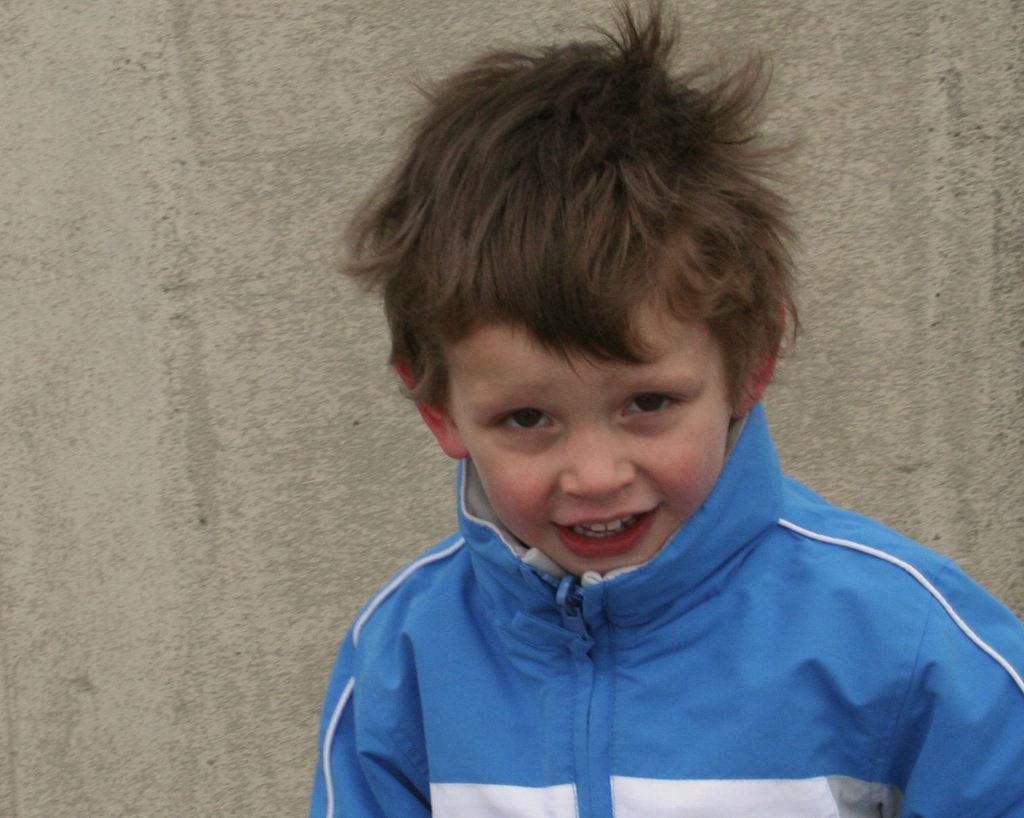Can you describe this image briefly? In the image in the center we can see one boy standing and he is smiling,which we can see on his face. And we can see he is wearing blue and white color jacket. In the background there is a wall. 